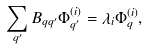Convert formula to latex. <formula><loc_0><loc_0><loc_500><loc_500>\sum _ { q ^ { \prime } } B _ { q q ^ { \prime } } \Phi _ { q ^ { \prime } } ^ { ( i ) } = \lambda _ { i } \Phi _ { q } ^ { ( i ) } ,</formula> 